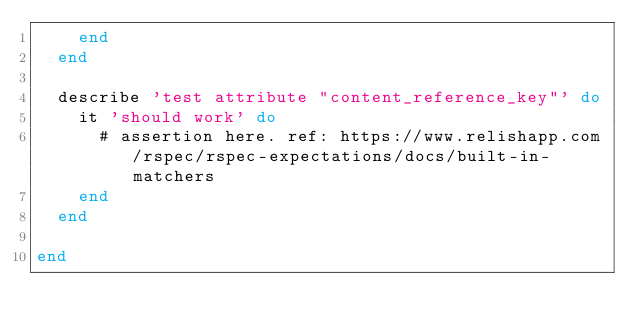Convert code to text. <code><loc_0><loc_0><loc_500><loc_500><_Ruby_>    end
  end

  describe 'test attribute "content_reference_key"' do
    it 'should work' do
      # assertion here. ref: https://www.relishapp.com/rspec/rspec-expectations/docs/built-in-matchers
    end
  end

end
</code> 